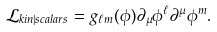Convert formula to latex. <formula><loc_0><loc_0><loc_500><loc_500>\mathcal { L } _ { k i n | s c a l a r s } = g _ { \ell m } ( \phi ) \partial _ { \mu } \phi ^ { \ell } \partial ^ { \mu } \phi ^ { m } .</formula> 